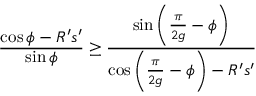Convert formula to latex. <formula><loc_0><loc_0><loc_500><loc_500>\frac { \cos \phi - R ^ { \prime } s ^ { \prime } } { \sin \phi } \geq \frac { \sin \left ( \frac { \pi } { 2 g } - \phi \right ) } { \cos \left ( \frac { \pi } { 2 g } - \phi \right ) - R ^ { \prime } s ^ { \prime } }</formula> 